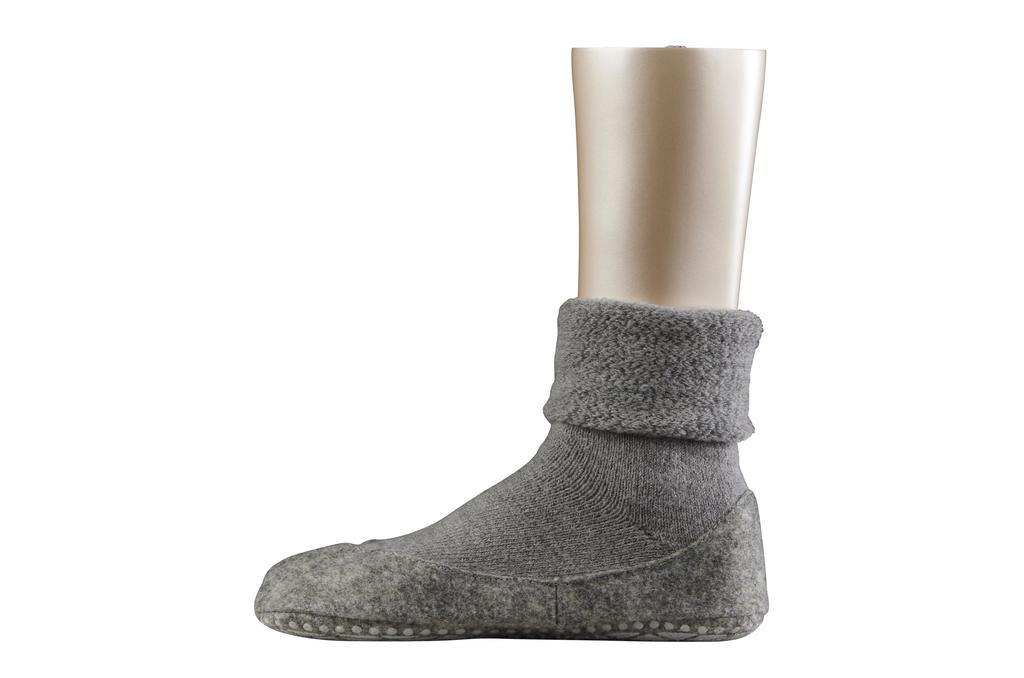What color is the shoe in the image? The shoe in the image is grey-colored. What is paired with the shoe in the image? There is a grey-colored sock in the image. What other object with a different color can be seen in the image? There is a golden-colored object in the image. What type of toys are being played with in the image? There are no toys present in the image. What level of difficulty is the game set to in the image? There is no game present in the image, so it is not possible to determine the level of difficulty. 